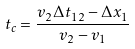Convert formula to latex. <formula><loc_0><loc_0><loc_500><loc_500>t _ { c } = \frac { v _ { 2 } \Delta t _ { 1 2 } - \Delta x _ { 1 } } { v _ { 2 } - v _ { 1 } }</formula> 